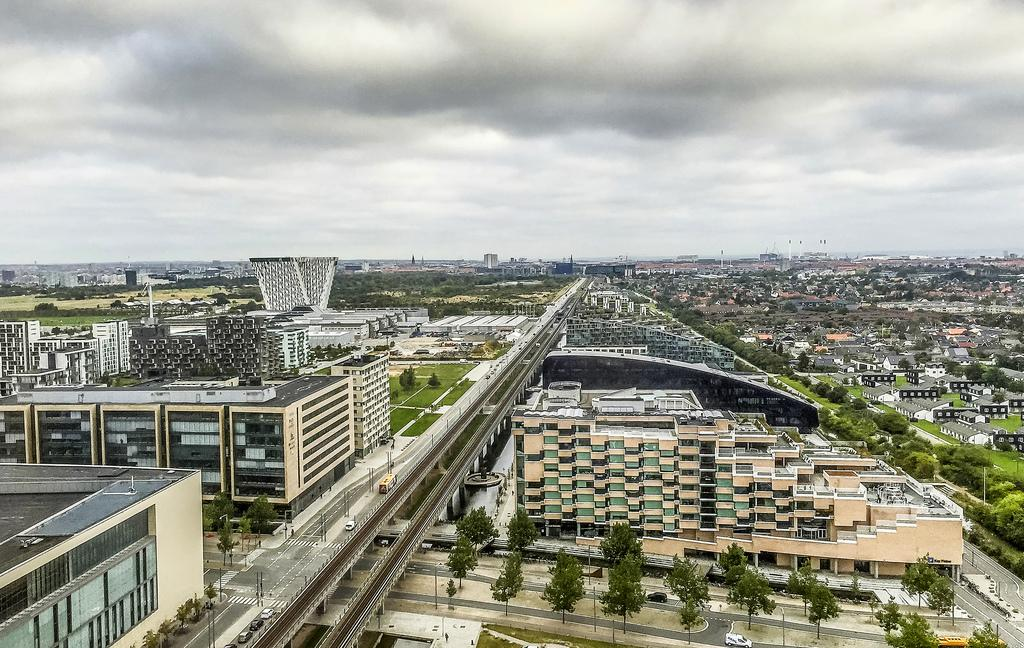What types of structures are located at the bottom of the image? There are many buildings at the bottom of the image. What else can be seen at the bottom of the image besides buildings? Trees and plants are also visible at the bottom of the image. What type of transportation infrastructure is present in the image? Roads and flyovers are present in the image. How many poles can be seen in the image? There are many poles in the image. What is visible at the top of the image? The sky is visible at the top of the image. What can be seen in the sky? Clouds are present in the sky. What type of knee is visible in the image? There is no knee present in the image. What color is the underwear worn by the trees in the image? There are no trees wearing underwear in the image. 